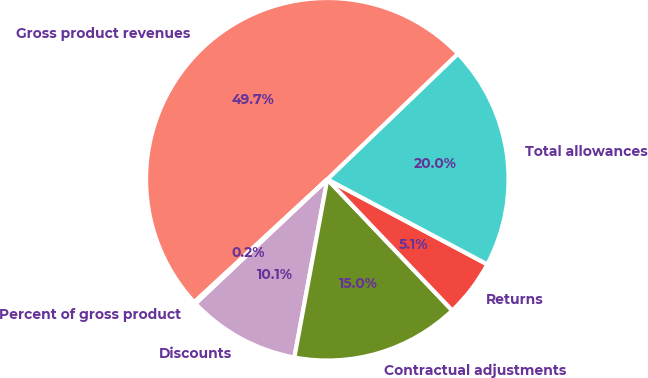<chart> <loc_0><loc_0><loc_500><loc_500><pie_chart><fcel>Discounts<fcel>Contractual adjustments<fcel>Returns<fcel>Total allowances<fcel>Gross product revenues<fcel>Percent of gross product<nl><fcel>10.06%<fcel>15.02%<fcel>5.11%<fcel>19.97%<fcel>49.68%<fcel>0.16%<nl></chart> 